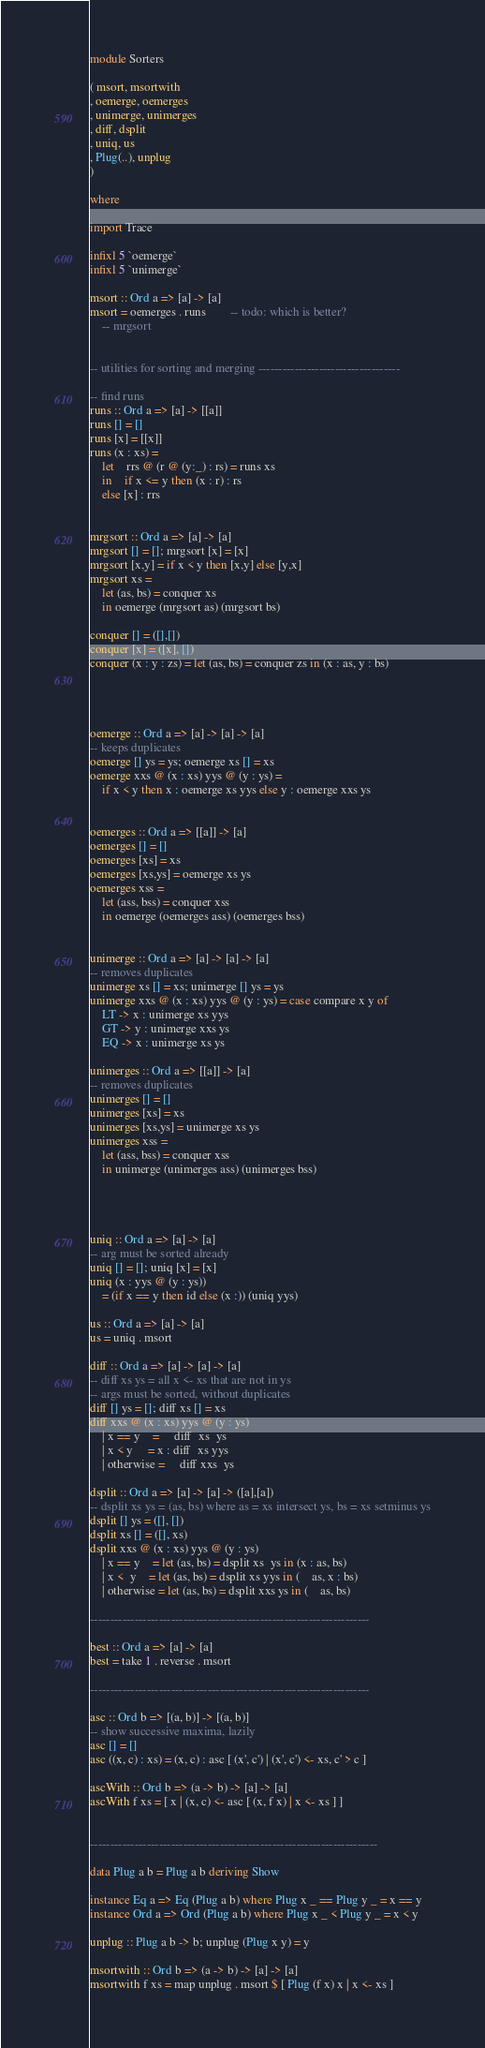<code> <loc_0><loc_0><loc_500><loc_500><_Haskell_>module Sorters 

( msort, msortwith
, oemerge, oemerges
, unimerge, unimerges
, diff, dsplit
, uniq, us
, Plug(..), unplug
) 

where

import Trace

infixl 5 `oemerge`
infixl 5 `unimerge`

msort :: Ord a => [a] -> [a]
msort = oemerges . runs		-- todo: which is better?
	-- mrgsort
	

-- utilities for sorting and merging -----------------------------------

-- find runs
runs :: Ord a => [a] -> [[a]]
runs [] = []
runs [x] = [[x]]
runs (x : xs) = 
    let	rrs @ (r @ (y:_) : rs) = runs xs
    in	if x <= y then (x : r) : rs
	else [x] : rrs


mrgsort :: Ord a => [a] -> [a]
mrgsort [] = []; mrgsort [x] = [x]
mrgsort [x,y] = if x < y then [x,y] else [y,x]
mrgsort xs = 
    let (as, bs) = conquer xs
    in oemerge (mrgsort as) (mrgsort bs)

conquer [] = ([],[])
conquer [x] = ([x], [])
conquer (x : y : zs) = let (as, bs) = conquer zs in (x : as, y : bs)




oemerge :: Ord a => [a] -> [a] -> [a]
-- keeps duplicates
oemerge [] ys = ys; oemerge xs [] = xs
oemerge xxs @ (x : xs) yys @ (y : ys) = 
    if x < y then x : oemerge xs yys else y : oemerge xxs ys


oemerges :: Ord a => [[a]] -> [a]
oemerges [] = []
oemerges [xs] = xs
oemerges [xs,ys] = oemerge xs ys
oemerges xss = 
	let (ass, bss) = conquer xss
	in oemerge (oemerges ass) (oemerges bss)


unimerge :: Ord a => [a] -> [a] -> [a]
-- removes duplicates
unimerge xs [] = xs; unimerge [] ys = ys
unimerge xxs @ (x : xs) yys @ (y : ys) = case compare x y of
	LT -> x : unimerge xs yys
	GT -> y : unimerge xxs ys
	EQ -> x : unimerge xs ys

unimerges :: Ord a => [[a]] -> [a]
-- removes duplicates
unimerges [] = []
unimerges [xs] = xs
unimerges [xs,ys] = unimerge xs ys
unimerges xss = 
	let (ass, bss) = conquer xss
	in unimerge (unimerges ass) (unimerges bss)




uniq :: Ord a => [a] -> [a]
-- arg must be sorted already
uniq [] = []; uniq [x] = [x]
uniq (x : yys @ (y : ys)) 
    = (if x == y then id else (x :)) (uniq yys)

us :: Ord a => [a] -> [a]
us = uniq . msort

diff :: Ord a => [a] -> [a] -> [a]
-- diff xs ys = all x <- xs that are not in ys
-- args must be sorted, without duplicates
diff [] ys = []; diff xs [] = xs
diff xxs @ (x : xs) yys @ (y : ys)
    | x == y    =     diff  xs  ys
    | x < y     = x : diff  xs yys
    | otherwise =     diff xxs  ys
 
dsplit :: Ord a => [a] -> [a] -> ([a],[a])
-- dsplit xs ys = (as, bs) where as = xs intersect ys, bs = xs setminus ys
dsplit [] ys = ([], [])
dsplit xs [] = ([], xs)
dsplit xxs @ (x : xs) yys @ (y : ys)
	| x == y    = let (as, bs) = dsplit xs  ys in (x : as, bs)
	| x <  y    = let (as, bs) = dsplit xs yys in (    as, x : bs)
	| otherwise = let (as, bs) = dsplit xxs ys in (    as, bs)

---------------------------------------------------------------------

best :: Ord a => [a] -> [a]
best = take 1 . reverse . msort

---------------------------------------------------------------------

asc :: Ord b => [(a, b)] -> [(a, b)]
-- show successive maxima, lazily
asc [] = []
asc ((x, c) : xs) = (x, c) : asc [ (x', c') | (x', c') <- xs, c' > c ]

ascWith :: Ord b => (a -> b) -> [a] -> [a]
ascWith f xs = [ x | (x, c) <- asc [ (x, f x) | x <- xs ] ]


-----------------------------------------------------------------------

data Plug a b = Plug a b deriving Show

instance Eq a => Eq (Plug a b) where Plug x _ == Plug y _ = x == y
instance Ord a => Ord (Plug a b) where Plug x _ < Plug y _ = x < y

unplug :: Plug a b -> b; unplug (Plug x y) = y

msortwith :: Ord b => (a -> b) -> [a] -> [a]
msortwith f xs = map unplug . msort $ [ Plug (f x) x | x <- xs ]
</code> 